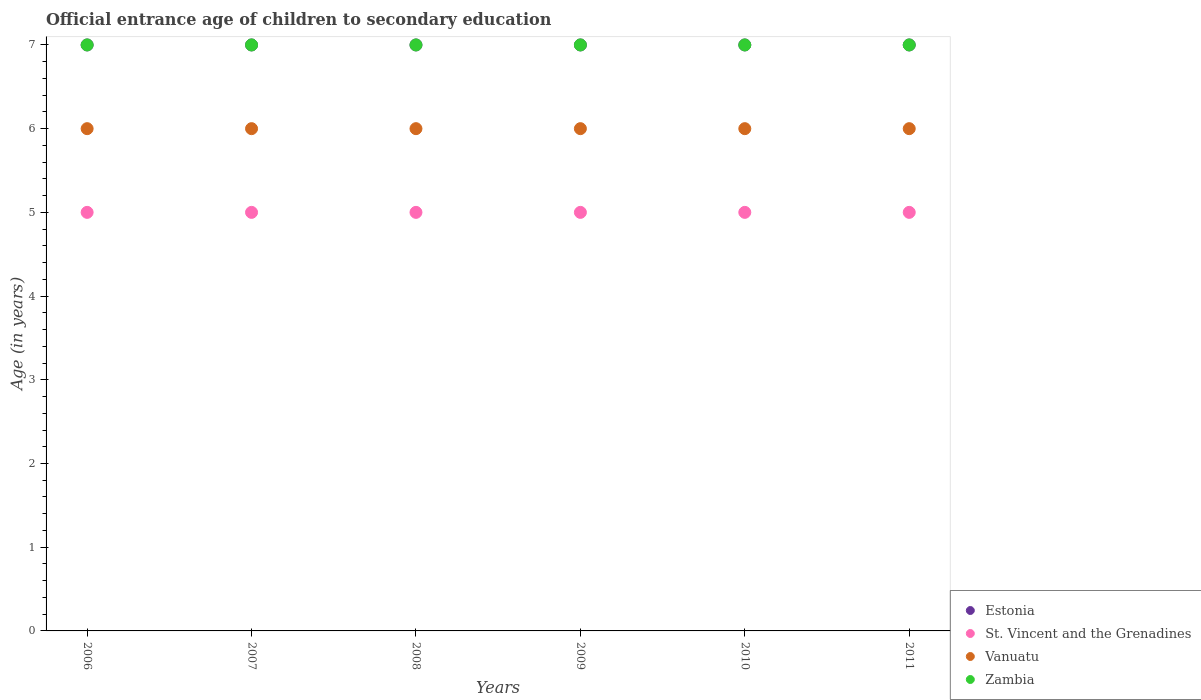What is the secondary school starting age of children in Estonia in 2011?
Keep it short and to the point. 7. Across all years, what is the maximum secondary school starting age of children in Vanuatu?
Ensure brevity in your answer.  6. What is the total secondary school starting age of children in Estonia in the graph?
Your response must be concise. 42. What is the difference between the secondary school starting age of children in Vanuatu in 2011 and the secondary school starting age of children in Estonia in 2010?
Your response must be concise. -1. What is the average secondary school starting age of children in Zambia per year?
Offer a very short reply. 7. Is the difference between the secondary school starting age of children in Zambia in 2007 and 2008 greater than the difference between the secondary school starting age of children in Estonia in 2007 and 2008?
Provide a succinct answer. No. What is the difference between the highest and the second highest secondary school starting age of children in Estonia?
Your answer should be compact. 0. Is the sum of the secondary school starting age of children in Estonia in 2006 and 2010 greater than the maximum secondary school starting age of children in Vanuatu across all years?
Ensure brevity in your answer.  Yes. Is it the case that in every year, the sum of the secondary school starting age of children in Zambia and secondary school starting age of children in Vanuatu  is greater than the sum of secondary school starting age of children in Estonia and secondary school starting age of children in St. Vincent and the Grenadines?
Make the answer very short. No. How many years are there in the graph?
Your answer should be compact. 6. What is the difference between two consecutive major ticks on the Y-axis?
Give a very brief answer. 1. Does the graph contain grids?
Your answer should be very brief. No. Where does the legend appear in the graph?
Give a very brief answer. Bottom right. How many legend labels are there?
Provide a succinct answer. 4. How are the legend labels stacked?
Your answer should be compact. Vertical. What is the title of the graph?
Your answer should be compact. Official entrance age of children to secondary education. Does "Samoa" appear as one of the legend labels in the graph?
Make the answer very short. No. What is the label or title of the X-axis?
Your response must be concise. Years. What is the label or title of the Y-axis?
Provide a succinct answer. Age (in years). What is the Age (in years) in Zambia in 2006?
Ensure brevity in your answer.  7. What is the Age (in years) of Vanuatu in 2007?
Keep it short and to the point. 6. What is the Age (in years) in Estonia in 2008?
Keep it short and to the point. 7. What is the Age (in years) in Vanuatu in 2008?
Keep it short and to the point. 6. What is the Age (in years) of Vanuatu in 2009?
Offer a terse response. 6. What is the Age (in years) in St. Vincent and the Grenadines in 2010?
Your answer should be compact. 5. What is the Age (in years) in St. Vincent and the Grenadines in 2011?
Your answer should be compact. 5. Across all years, what is the maximum Age (in years) in St. Vincent and the Grenadines?
Offer a terse response. 5. Across all years, what is the maximum Age (in years) in Vanuatu?
Keep it short and to the point. 6. Across all years, what is the minimum Age (in years) of Zambia?
Keep it short and to the point. 7. What is the total Age (in years) of Estonia in the graph?
Ensure brevity in your answer.  42. What is the total Age (in years) of St. Vincent and the Grenadines in the graph?
Offer a very short reply. 30. What is the total Age (in years) of Vanuatu in the graph?
Your response must be concise. 36. What is the difference between the Age (in years) in St. Vincent and the Grenadines in 2006 and that in 2007?
Keep it short and to the point. 0. What is the difference between the Age (in years) in Vanuatu in 2006 and that in 2007?
Give a very brief answer. 0. What is the difference between the Age (in years) of Zambia in 2006 and that in 2007?
Your response must be concise. 0. What is the difference between the Age (in years) in Vanuatu in 2006 and that in 2008?
Your answer should be very brief. 0. What is the difference between the Age (in years) in Zambia in 2006 and that in 2008?
Keep it short and to the point. 0. What is the difference between the Age (in years) in St. Vincent and the Grenadines in 2006 and that in 2009?
Ensure brevity in your answer.  0. What is the difference between the Age (in years) of Estonia in 2006 and that in 2010?
Your response must be concise. 0. What is the difference between the Age (in years) in St. Vincent and the Grenadines in 2006 and that in 2010?
Provide a succinct answer. 0. What is the difference between the Age (in years) of Vanuatu in 2006 and that in 2010?
Your answer should be very brief. 0. What is the difference between the Age (in years) in Zambia in 2006 and that in 2010?
Provide a short and direct response. 0. What is the difference between the Age (in years) of Estonia in 2006 and that in 2011?
Offer a terse response. 0. What is the difference between the Age (in years) in Vanuatu in 2006 and that in 2011?
Offer a terse response. 0. What is the difference between the Age (in years) in St. Vincent and the Grenadines in 2007 and that in 2008?
Make the answer very short. 0. What is the difference between the Age (in years) in Zambia in 2007 and that in 2008?
Provide a short and direct response. 0. What is the difference between the Age (in years) in Vanuatu in 2007 and that in 2009?
Your answer should be compact. 0. What is the difference between the Age (in years) of St. Vincent and the Grenadines in 2007 and that in 2010?
Offer a very short reply. 0. What is the difference between the Age (in years) of Estonia in 2007 and that in 2011?
Your answer should be very brief. 0. What is the difference between the Age (in years) in St. Vincent and the Grenadines in 2007 and that in 2011?
Your response must be concise. 0. What is the difference between the Age (in years) in Vanuatu in 2008 and that in 2009?
Provide a succinct answer. 0. What is the difference between the Age (in years) in Zambia in 2008 and that in 2009?
Provide a succinct answer. 0. What is the difference between the Age (in years) of Zambia in 2008 and that in 2010?
Give a very brief answer. 0. What is the difference between the Age (in years) in Estonia in 2008 and that in 2011?
Your response must be concise. 0. What is the difference between the Age (in years) of St. Vincent and the Grenadines in 2008 and that in 2011?
Offer a terse response. 0. What is the difference between the Age (in years) of Vanuatu in 2008 and that in 2011?
Offer a very short reply. 0. What is the difference between the Age (in years) of Zambia in 2008 and that in 2011?
Provide a short and direct response. 0. What is the difference between the Age (in years) of Estonia in 2009 and that in 2010?
Offer a terse response. 0. What is the difference between the Age (in years) in St. Vincent and the Grenadines in 2009 and that in 2010?
Offer a very short reply. 0. What is the difference between the Age (in years) in Vanuatu in 2009 and that in 2010?
Offer a terse response. 0. What is the difference between the Age (in years) of Zambia in 2009 and that in 2010?
Your answer should be very brief. 0. What is the difference between the Age (in years) in Vanuatu in 2009 and that in 2011?
Give a very brief answer. 0. What is the difference between the Age (in years) of Zambia in 2009 and that in 2011?
Offer a very short reply. 0. What is the difference between the Age (in years) of Estonia in 2010 and that in 2011?
Your answer should be very brief. 0. What is the difference between the Age (in years) of Vanuatu in 2010 and that in 2011?
Give a very brief answer. 0. What is the difference between the Age (in years) of Estonia in 2006 and the Age (in years) of St. Vincent and the Grenadines in 2007?
Make the answer very short. 2. What is the difference between the Age (in years) of St. Vincent and the Grenadines in 2006 and the Age (in years) of Vanuatu in 2007?
Provide a succinct answer. -1. What is the difference between the Age (in years) in St. Vincent and the Grenadines in 2006 and the Age (in years) in Zambia in 2007?
Keep it short and to the point. -2. What is the difference between the Age (in years) in Estonia in 2006 and the Age (in years) in Vanuatu in 2008?
Make the answer very short. 1. What is the difference between the Age (in years) of Estonia in 2006 and the Age (in years) of Zambia in 2008?
Offer a very short reply. 0. What is the difference between the Age (in years) in St. Vincent and the Grenadines in 2006 and the Age (in years) in Vanuatu in 2008?
Make the answer very short. -1. What is the difference between the Age (in years) of St. Vincent and the Grenadines in 2006 and the Age (in years) of Zambia in 2008?
Offer a very short reply. -2. What is the difference between the Age (in years) of Vanuatu in 2006 and the Age (in years) of Zambia in 2008?
Make the answer very short. -1. What is the difference between the Age (in years) in Estonia in 2006 and the Age (in years) in St. Vincent and the Grenadines in 2009?
Your answer should be very brief. 2. What is the difference between the Age (in years) of Estonia in 2006 and the Age (in years) of Vanuatu in 2009?
Your response must be concise. 1. What is the difference between the Age (in years) in Estonia in 2006 and the Age (in years) in Zambia in 2010?
Your response must be concise. 0. What is the difference between the Age (in years) of Estonia in 2006 and the Age (in years) of Vanuatu in 2011?
Your response must be concise. 1. What is the difference between the Age (in years) in St. Vincent and the Grenadines in 2006 and the Age (in years) in Vanuatu in 2011?
Give a very brief answer. -1. What is the difference between the Age (in years) in Vanuatu in 2006 and the Age (in years) in Zambia in 2011?
Offer a very short reply. -1. What is the difference between the Age (in years) in Vanuatu in 2007 and the Age (in years) in Zambia in 2008?
Provide a short and direct response. -1. What is the difference between the Age (in years) of Estonia in 2007 and the Age (in years) of St. Vincent and the Grenadines in 2009?
Offer a very short reply. 2. What is the difference between the Age (in years) of St. Vincent and the Grenadines in 2007 and the Age (in years) of Zambia in 2009?
Your answer should be very brief. -2. What is the difference between the Age (in years) of Estonia in 2007 and the Age (in years) of Vanuatu in 2010?
Offer a very short reply. 1. What is the difference between the Age (in years) in Estonia in 2007 and the Age (in years) in Zambia in 2010?
Give a very brief answer. 0. What is the difference between the Age (in years) in St. Vincent and the Grenadines in 2007 and the Age (in years) in Zambia in 2010?
Ensure brevity in your answer.  -2. What is the difference between the Age (in years) of Estonia in 2007 and the Age (in years) of St. Vincent and the Grenadines in 2011?
Provide a short and direct response. 2. What is the difference between the Age (in years) in Estonia in 2007 and the Age (in years) in Zambia in 2011?
Provide a short and direct response. 0. What is the difference between the Age (in years) in St. Vincent and the Grenadines in 2007 and the Age (in years) in Zambia in 2011?
Ensure brevity in your answer.  -2. What is the difference between the Age (in years) in Estonia in 2008 and the Age (in years) in Vanuatu in 2009?
Offer a terse response. 1. What is the difference between the Age (in years) of Estonia in 2008 and the Age (in years) of Zambia in 2009?
Your answer should be very brief. 0. What is the difference between the Age (in years) in St. Vincent and the Grenadines in 2008 and the Age (in years) in Zambia in 2009?
Give a very brief answer. -2. What is the difference between the Age (in years) of Estonia in 2008 and the Age (in years) of St. Vincent and the Grenadines in 2010?
Keep it short and to the point. 2. What is the difference between the Age (in years) of Vanuatu in 2008 and the Age (in years) of Zambia in 2010?
Offer a very short reply. -1. What is the difference between the Age (in years) in Estonia in 2008 and the Age (in years) in St. Vincent and the Grenadines in 2011?
Your answer should be compact. 2. What is the difference between the Age (in years) in St. Vincent and the Grenadines in 2008 and the Age (in years) in Zambia in 2011?
Keep it short and to the point. -2. What is the difference between the Age (in years) of Estonia in 2009 and the Age (in years) of Vanuatu in 2010?
Offer a terse response. 1. What is the difference between the Age (in years) in St. Vincent and the Grenadines in 2009 and the Age (in years) in Zambia in 2010?
Make the answer very short. -2. What is the difference between the Age (in years) of St. Vincent and the Grenadines in 2009 and the Age (in years) of Zambia in 2011?
Give a very brief answer. -2. What is the difference between the Age (in years) of Vanuatu in 2009 and the Age (in years) of Zambia in 2011?
Give a very brief answer. -1. What is the difference between the Age (in years) in Estonia in 2010 and the Age (in years) in Zambia in 2011?
Ensure brevity in your answer.  0. What is the difference between the Age (in years) of St. Vincent and the Grenadines in 2010 and the Age (in years) of Zambia in 2011?
Your response must be concise. -2. What is the average Age (in years) in Estonia per year?
Give a very brief answer. 7. What is the average Age (in years) in Vanuatu per year?
Offer a terse response. 6. In the year 2006, what is the difference between the Age (in years) in Estonia and Age (in years) in St. Vincent and the Grenadines?
Give a very brief answer. 2. In the year 2006, what is the difference between the Age (in years) in Estonia and Age (in years) in Vanuatu?
Your answer should be very brief. 1. In the year 2007, what is the difference between the Age (in years) in Estonia and Age (in years) in Zambia?
Provide a succinct answer. 0. In the year 2008, what is the difference between the Age (in years) in Estonia and Age (in years) in Vanuatu?
Your response must be concise. 1. In the year 2008, what is the difference between the Age (in years) in Estonia and Age (in years) in Zambia?
Provide a succinct answer. 0. In the year 2008, what is the difference between the Age (in years) of St. Vincent and the Grenadines and Age (in years) of Vanuatu?
Ensure brevity in your answer.  -1. In the year 2009, what is the difference between the Age (in years) of Estonia and Age (in years) of St. Vincent and the Grenadines?
Your answer should be very brief. 2. In the year 2009, what is the difference between the Age (in years) in St. Vincent and the Grenadines and Age (in years) in Vanuatu?
Offer a terse response. -1. In the year 2010, what is the difference between the Age (in years) in Estonia and Age (in years) in St. Vincent and the Grenadines?
Your answer should be very brief. 2. In the year 2010, what is the difference between the Age (in years) in Estonia and Age (in years) in Vanuatu?
Keep it short and to the point. 1. In the year 2010, what is the difference between the Age (in years) in Estonia and Age (in years) in Zambia?
Ensure brevity in your answer.  0. In the year 2010, what is the difference between the Age (in years) in St. Vincent and the Grenadines and Age (in years) in Zambia?
Provide a short and direct response. -2. In the year 2010, what is the difference between the Age (in years) in Vanuatu and Age (in years) in Zambia?
Offer a terse response. -1. In the year 2011, what is the difference between the Age (in years) in Estonia and Age (in years) in Zambia?
Offer a very short reply. 0. In the year 2011, what is the difference between the Age (in years) of St. Vincent and the Grenadines and Age (in years) of Vanuatu?
Keep it short and to the point. -1. What is the ratio of the Age (in years) in St. Vincent and the Grenadines in 2006 to that in 2007?
Your answer should be very brief. 1. What is the ratio of the Age (in years) of Zambia in 2006 to that in 2007?
Your response must be concise. 1. What is the ratio of the Age (in years) in Estonia in 2006 to that in 2008?
Provide a succinct answer. 1. What is the ratio of the Age (in years) in Estonia in 2006 to that in 2009?
Keep it short and to the point. 1. What is the ratio of the Age (in years) in Vanuatu in 2006 to that in 2009?
Ensure brevity in your answer.  1. What is the ratio of the Age (in years) in Estonia in 2006 to that in 2010?
Provide a succinct answer. 1. What is the ratio of the Age (in years) of St. Vincent and the Grenadines in 2006 to that in 2010?
Offer a terse response. 1. What is the ratio of the Age (in years) in Vanuatu in 2006 to that in 2010?
Provide a succinct answer. 1. What is the ratio of the Age (in years) of Estonia in 2006 to that in 2011?
Your response must be concise. 1. What is the ratio of the Age (in years) in St. Vincent and the Grenadines in 2006 to that in 2011?
Provide a succinct answer. 1. What is the ratio of the Age (in years) in Zambia in 2006 to that in 2011?
Keep it short and to the point. 1. What is the ratio of the Age (in years) of Vanuatu in 2007 to that in 2008?
Keep it short and to the point. 1. What is the ratio of the Age (in years) of Zambia in 2007 to that in 2008?
Your answer should be compact. 1. What is the ratio of the Age (in years) of St. Vincent and the Grenadines in 2007 to that in 2009?
Provide a succinct answer. 1. What is the ratio of the Age (in years) of Estonia in 2007 to that in 2010?
Ensure brevity in your answer.  1. What is the ratio of the Age (in years) of St. Vincent and the Grenadines in 2007 to that in 2010?
Provide a short and direct response. 1. What is the ratio of the Age (in years) in Vanuatu in 2007 to that in 2010?
Offer a terse response. 1. What is the ratio of the Age (in years) in Zambia in 2007 to that in 2010?
Provide a succinct answer. 1. What is the ratio of the Age (in years) in Estonia in 2007 to that in 2011?
Provide a short and direct response. 1. What is the ratio of the Age (in years) in Vanuatu in 2007 to that in 2011?
Offer a terse response. 1. What is the ratio of the Age (in years) of Estonia in 2008 to that in 2009?
Provide a short and direct response. 1. What is the ratio of the Age (in years) in St. Vincent and the Grenadines in 2008 to that in 2010?
Ensure brevity in your answer.  1. What is the ratio of the Age (in years) in Estonia in 2009 to that in 2010?
Keep it short and to the point. 1. What is the ratio of the Age (in years) in Vanuatu in 2009 to that in 2010?
Offer a very short reply. 1. What is the ratio of the Age (in years) of Zambia in 2009 to that in 2010?
Give a very brief answer. 1. What is the ratio of the Age (in years) of Vanuatu in 2009 to that in 2011?
Give a very brief answer. 1. What is the ratio of the Age (in years) of Zambia in 2009 to that in 2011?
Provide a succinct answer. 1. What is the ratio of the Age (in years) in St. Vincent and the Grenadines in 2010 to that in 2011?
Keep it short and to the point. 1. What is the ratio of the Age (in years) in Zambia in 2010 to that in 2011?
Give a very brief answer. 1. What is the difference between the highest and the second highest Age (in years) of Estonia?
Your answer should be very brief. 0. What is the difference between the highest and the second highest Age (in years) in St. Vincent and the Grenadines?
Your answer should be compact. 0. What is the difference between the highest and the second highest Age (in years) of Vanuatu?
Your answer should be compact. 0. What is the difference between the highest and the lowest Age (in years) of Estonia?
Provide a short and direct response. 0. What is the difference between the highest and the lowest Age (in years) of Vanuatu?
Your answer should be compact. 0. 